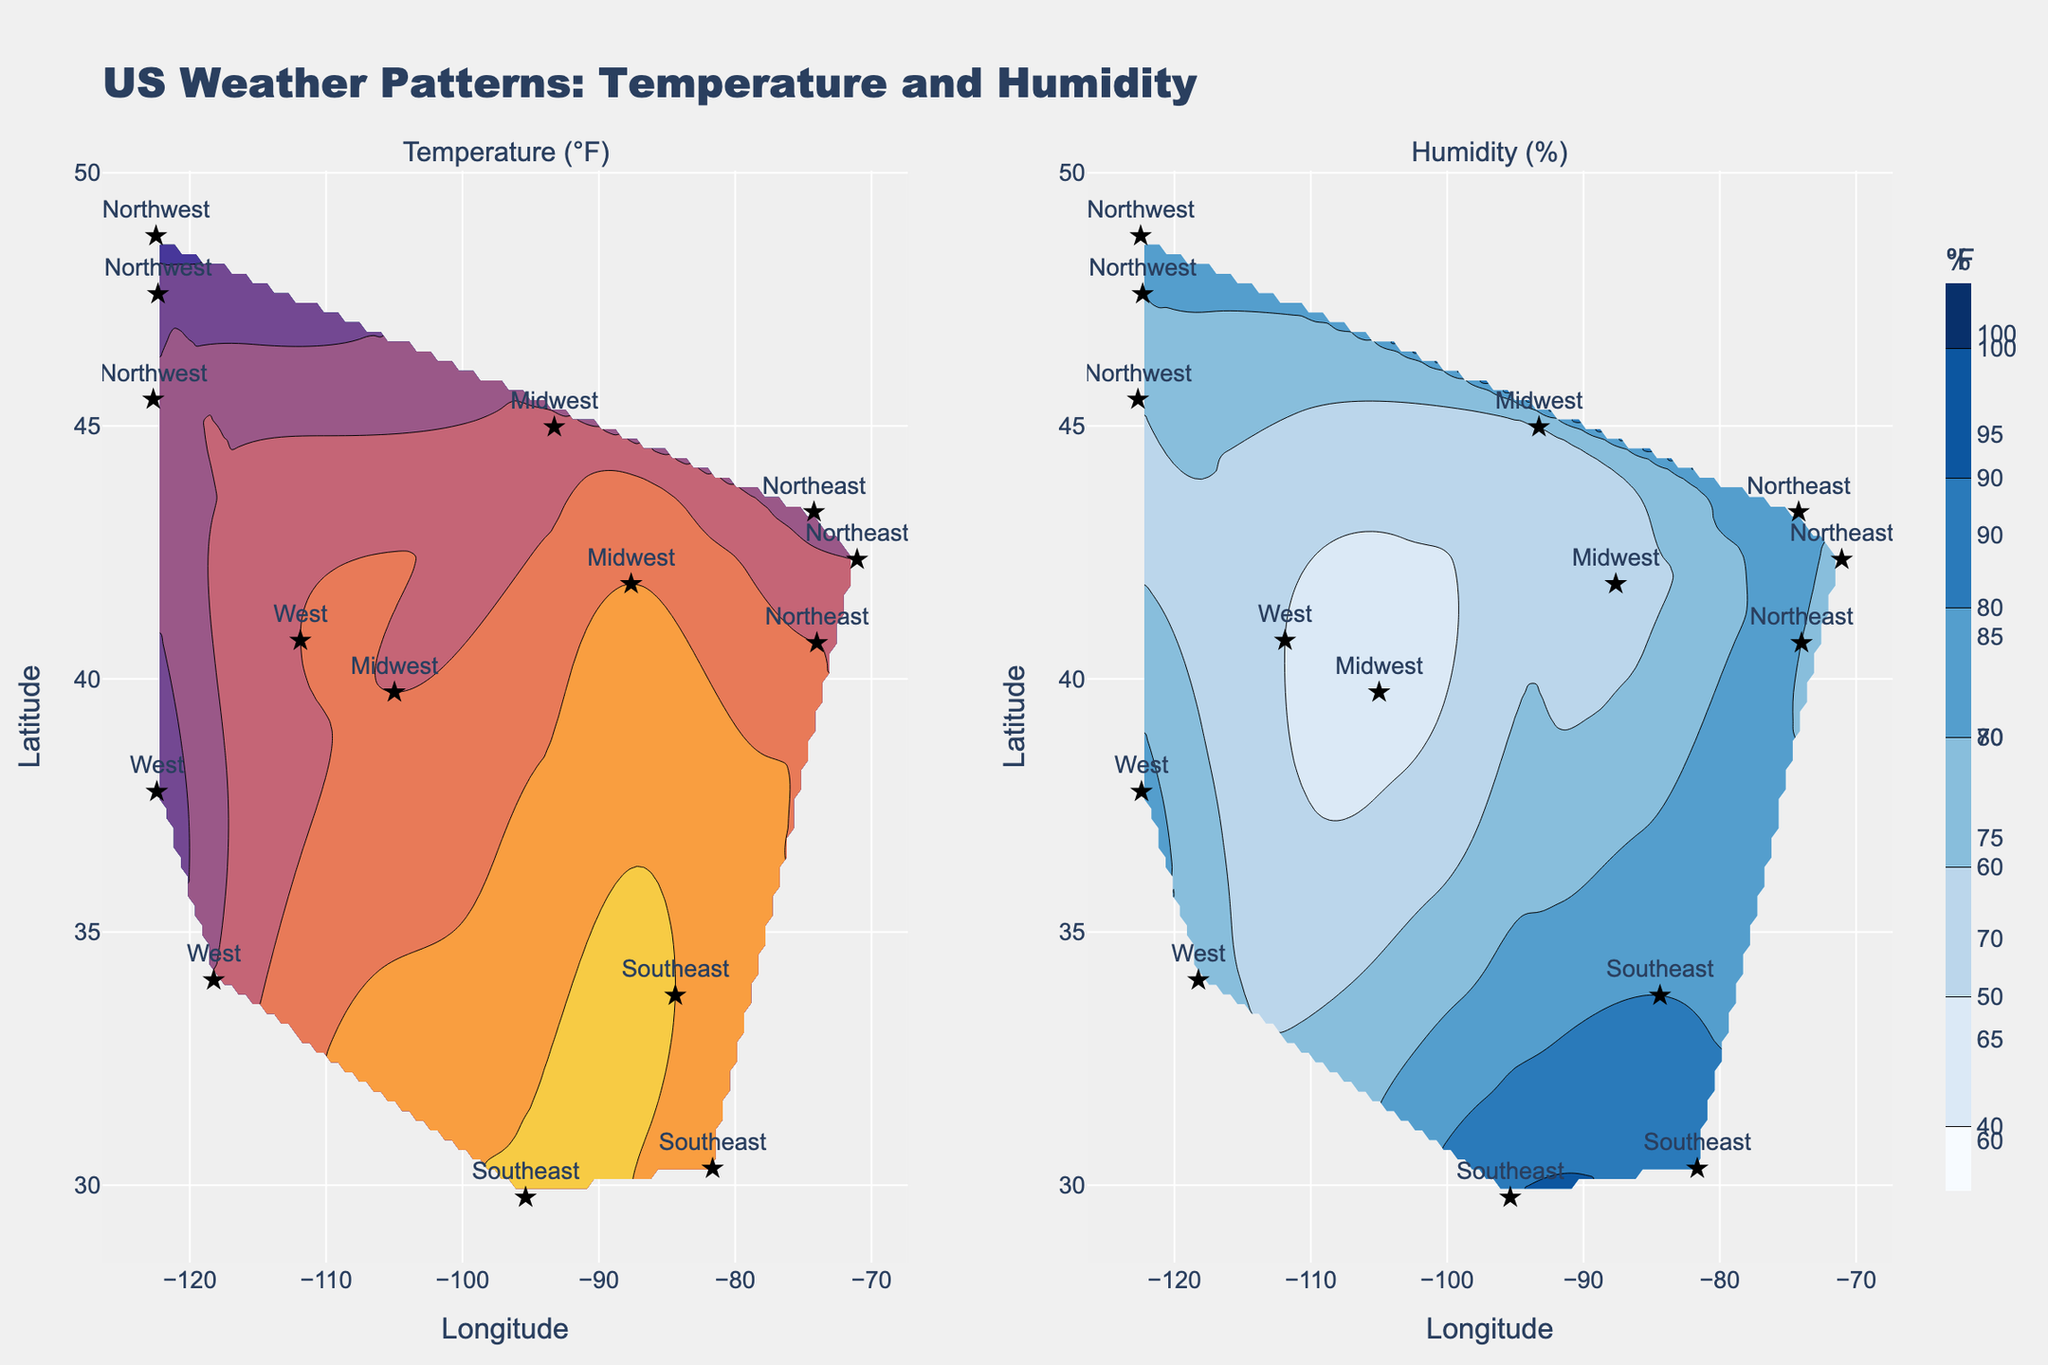which region has the highest temperature? The plot on the left shows temperature in degrees Fahrenheit. By examining the contour plot and the region labels, we see the highest temperature is 96°F in the Southeast (specifically in Houston, Texas).
Answer: Southeast what is the color scale used for the humidity levels? The plot on the right uses shades of blue to represent different humidity levels, getting darker as the humidity increases.
Answer: Blues how many regions are represented in the plots? The scatter points on both contour plots represent different regions. By counting the unique labels next to the points, we see there are five regions: Northeast, Midwest, Southeast, West, and Northwest.
Answer: five which region has the lowest humidity and what is its value? By inspecting the humidity contour plot on the right, we see the lowest humidity point marked in the Midwest, specifically in Denver (45%).
Answer: Midwest, 45% what's the average temperature of the Northeast region based on the data points? The data points for the Northeast region are 85, 80, and 78°F. To find the average, sum these values and divide by the number of data points: (85 + 80 + 78) / 3 = 81°F.
Answer: 81°F compare the temperature ranges between the Southeast and the Northwest regions. In the Southeast, the temperature ranges from 92°F to 96°F, while in the Northwest, it ranges from 68°F to 76°F. The Southeast has a higher temperature range.
Answer: Southeast has a higher range which regions are most similar in terms of temperature contour colors? The temperature contour plots compare temperature similarities. Both the Northeast and the West regions have overlapping colors from the Thermal scale around 70-85°F, indicating similar temperature levels.
Answer: Northeast and West in which region do we find the most significant difference between temperature and humidity levels? By comparing temperature and humidity plots, the Southeast region showcases significant differences with high temperatures (up to 96°F) and high humidity (up to 90%).
Answer: Southeast 